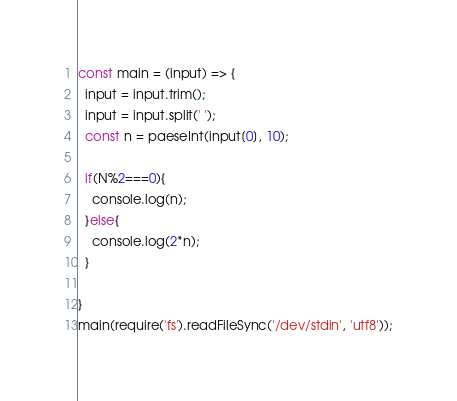Convert code to text. <code><loc_0><loc_0><loc_500><loc_500><_TypeScript_>const main = (input) => {
  input = input.trim();
  input = input.split(' ');
  const n = paeseInt(input[0], 10);
  
  if(N%2===0){
    console.log(n);
  }else{
    console.log(2*n);
  }
  
}
main(require('fs').readFileSync('/dev/stdin', 'utf8'));</code> 